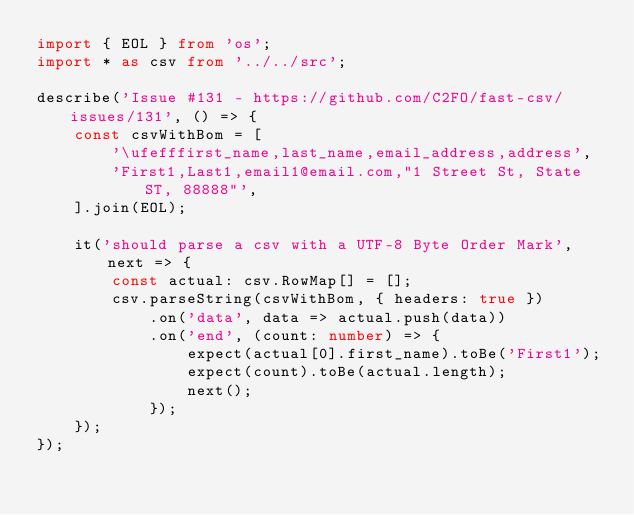Convert code to text. <code><loc_0><loc_0><loc_500><loc_500><_TypeScript_>import { EOL } from 'os';
import * as csv from '../../src';

describe('Issue #131 - https://github.com/C2FO/fast-csv/issues/131', () => {
    const csvWithBom = [
        '\ufefffirst_name,last_name,email_address,address',
        'First1,Last1,email1@email.com,"1 Street St, State ST, 88888"',
    ].join(EOL);

    it('should parse a csv with a UTF-8 Byte Order Mark', next => {
        const actual: csv.RowMap[] = [];
        csv.parseString(csvWithBom, { headers: true })
            .on('data', data => actual.push(data))
            .on('end', (count: number) => {
                expect(actual[0].first_name).toBe('First1');
                expect(count).toBe(actual.length);
                next();
            });
    });
});
</code> 